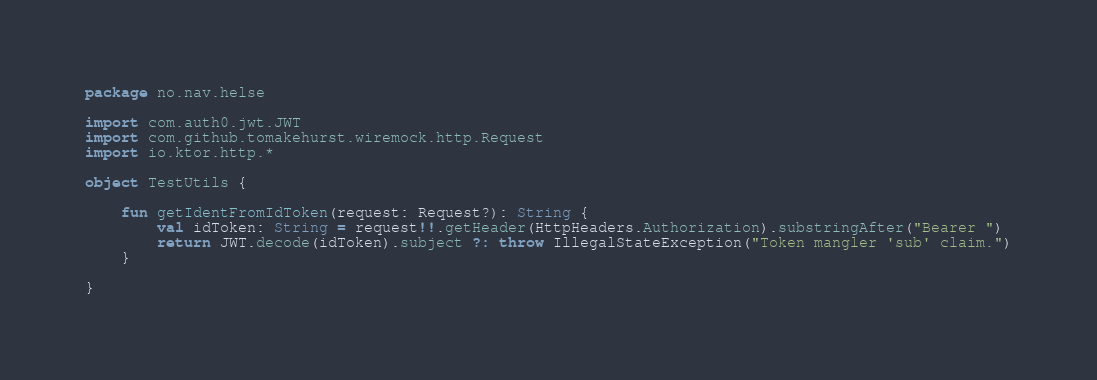Convert code to text. <code><loc_0><loc_0><loc_500><loc_500><_Kotlin_>package no.nav.helse

import com.auth0.jwt.JWT
import com.github.tomakehurst.wiremock.http.Request
import io.ktor.http.*

object TestUtils {

    fun getIdentFromIdToken(request: Request?): String {
        val idToken: String = request!!.getHeader(HttpHeaders.Authorization).substringAfter("Bearer ")
        return JWT.decode(idToken).subject ?: throw IllegalStateException("Token mangler 'sub' claim.")
    }

}</code> 